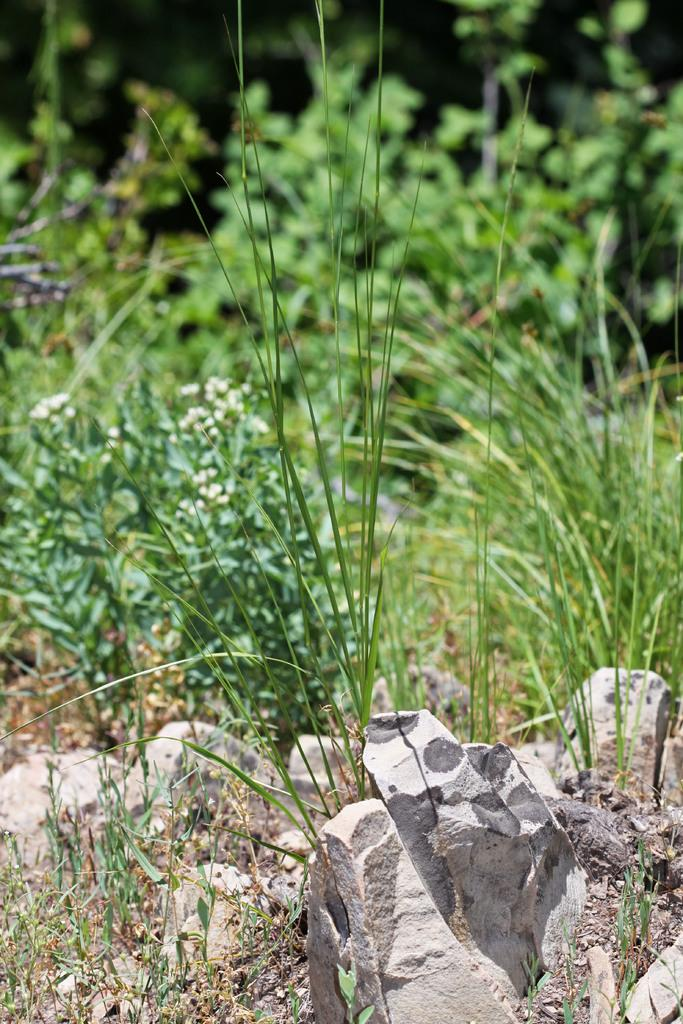What type of vegetation can be seen in the image? There are plants, flowers, and grass in the image. What other objects are present in the image besides vegetation? There are stones in the image. What type of cake is being served in the hospital during the birth scene in the image? There is no cake, hospital, or birth scene present in the image; it features plants, flowers, stones, and grass. 